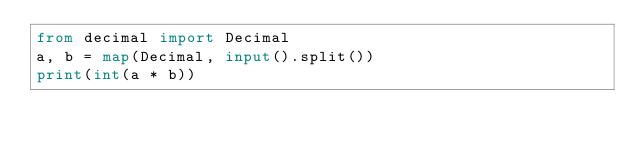Convert code to text. <code><loc_0><loc_0><loc_500><loc_500><_Python_>from decimal import Decimal
a, b = map(Decimal, input().split())
print(int(a * b))</code> 